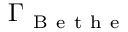<formula> <loc_0><loc_0><loc_500><loc_500>\Gamma _ { B e t h e }</formula> 